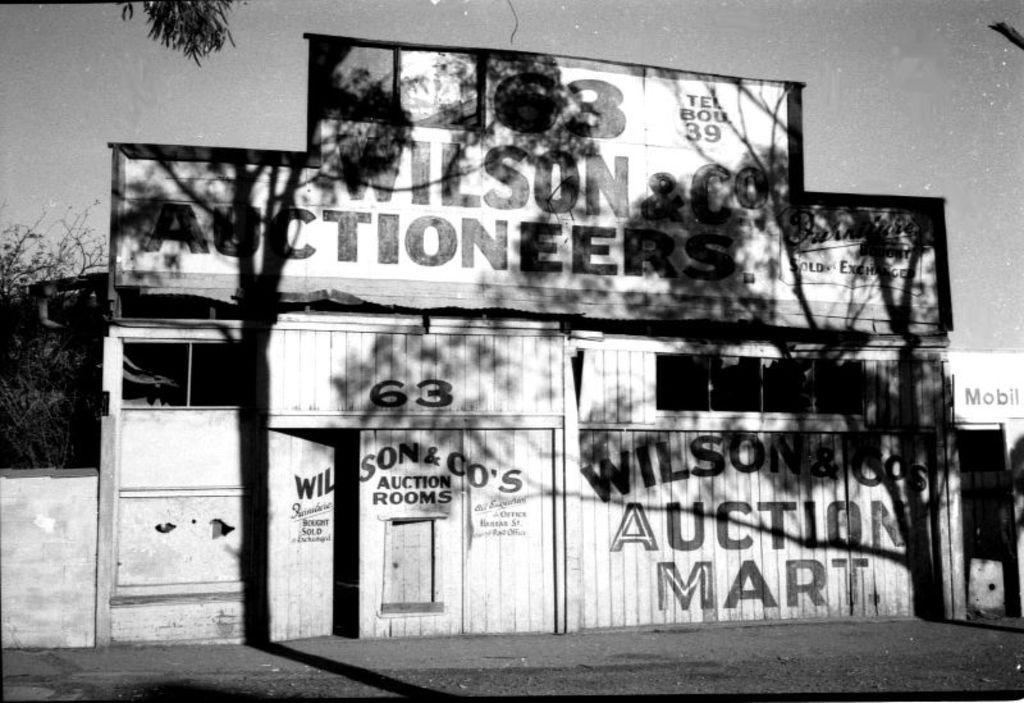Could you give a brief overview of what you see in this image? In this picture we can see the ground, beside this ground we can see a wooden wall, here we can see posters and some objects and in the background we can see trees, sky. 